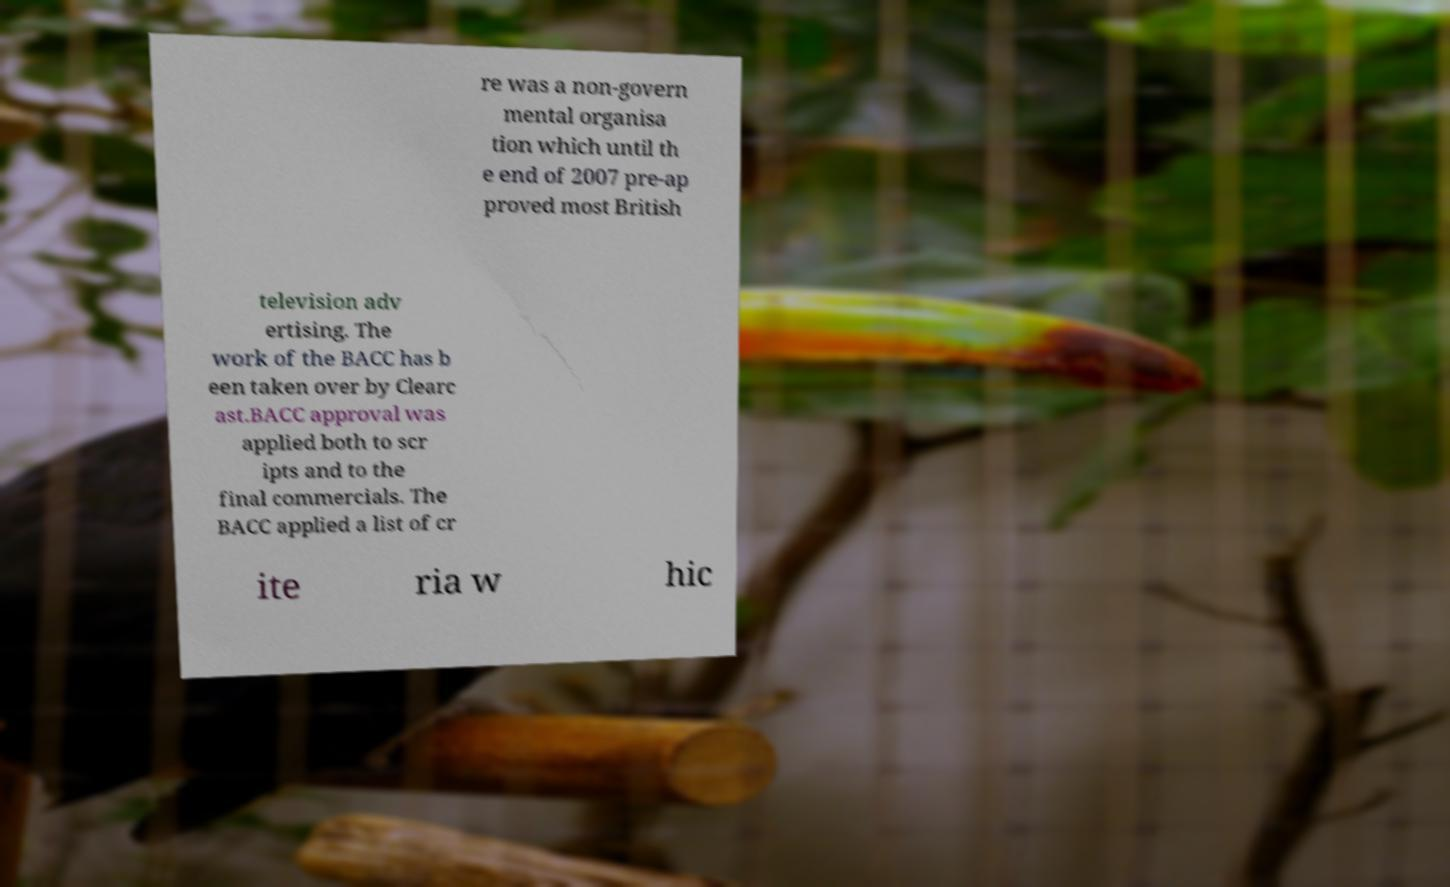What messages or text are displayed in this image? I need them in a readable, typed format. re was a non-govern mental organisa tion which until th e end of 2007 pre-ap proved most British television adv ertising. The work of the BACC has b een taken over by Clearc ast.BACC approval was applied both to scr ipts and to the final commercials. The BACC applied a list of cr ite ria w hic 